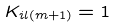Convert formula to latex. <formula><loc_0><loc_0><loc_500><loc_500>K _ { i l ( m + 1 ) } = 1</formula> 